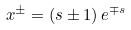<formula> <loc_0><loc_0><loc_500><loc_500>x ^ { \pm } = \left ( s \pm 1 \right ) e ^ { \mp s }</formula> 